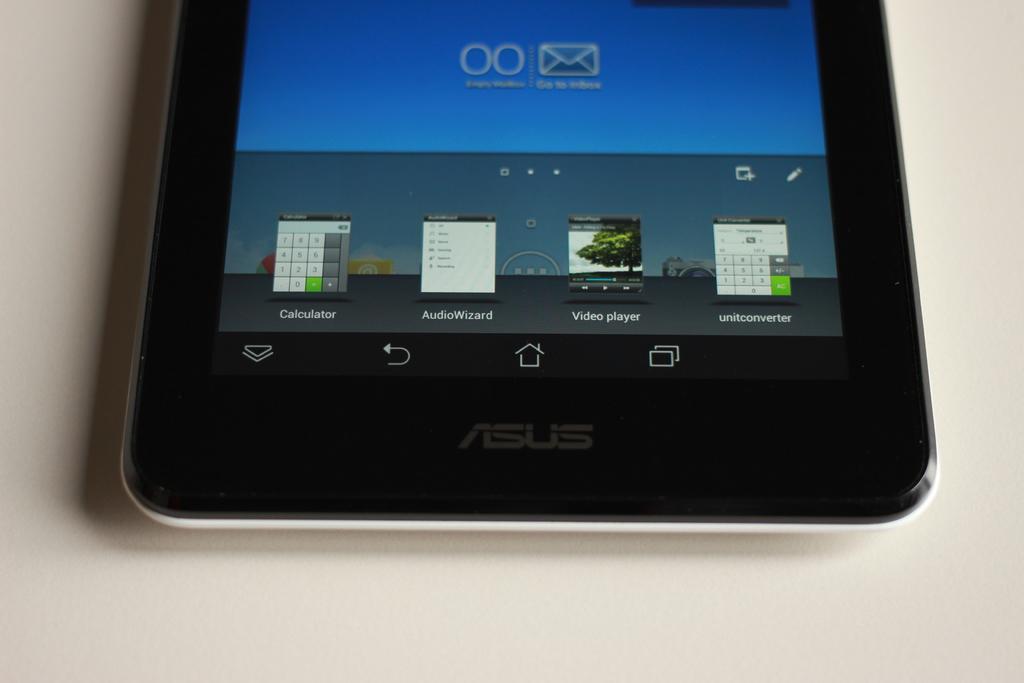Can you describe this image briefly? In this image I can see a mobile on a surface. On the mobile display I can see some icons. 